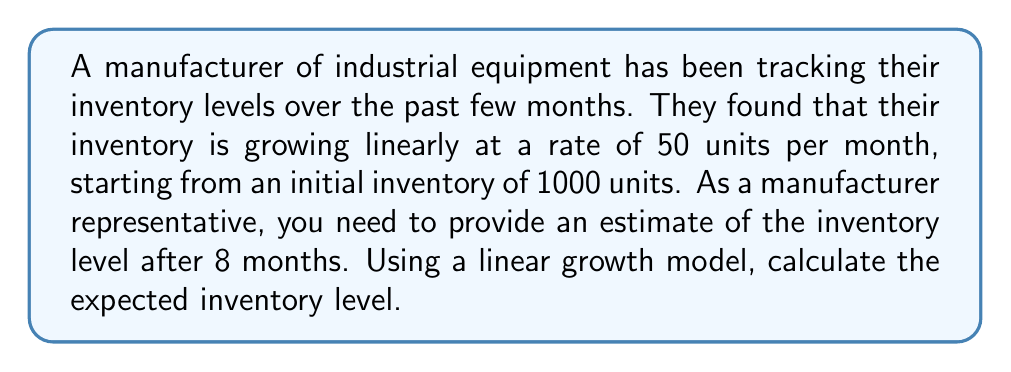Give your solution to this math problem. To solve this problem, we'll use a linear growth model. The general form of a linear equation is:

$$y = mx + b$$

Where:
$y$ = the dependent variable (inventory level)
$m$ = the slope (rate of change)
$x$ = the independent variable (time in months)
$b$ = the y-intercept (initial inventory)

Given information:
- Initial inventory (b) = 1000 units
- Growth rate (m) = 50 units per month
- Time (x) = 8 months

Step 1: Plug the values into the linear equation:
$$y = 50x + 1000$$

Step 2: Substitute x with 8 (months):
$$y = 50(8) + 1000$$

Step 3: Solve the equation:
$$y = 400 + 1000 = 1400$$

Therefore, after 8 months, the estimated inventory level will be 1400 units.
Answer: 1400 units 